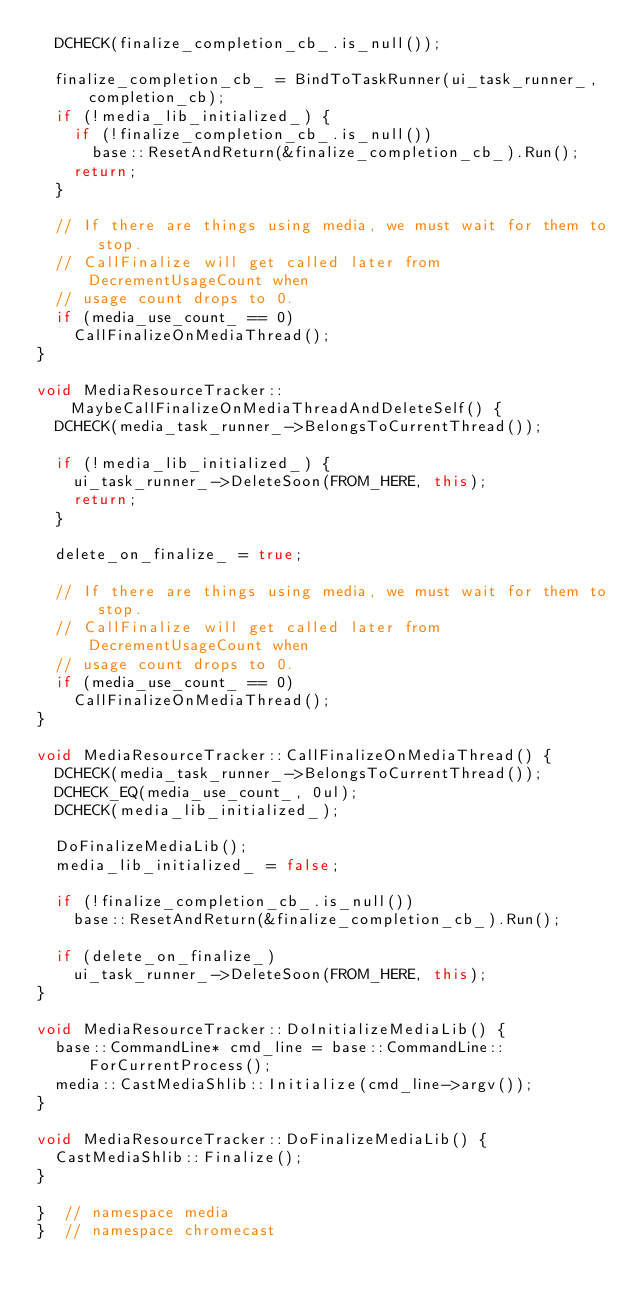<code> <loc_0><loc_0><loc_500><loc_500><_C++_>  DCHECK(finalize_completion_cb_.is_null());

  finalize_completion_cb_ = BindToTaskRunner(ui_task_runner_, completion_cb);
  if (!media_lib_initialized_) {
    if (!finalize_completion_cb_.is_null())
      base::ResetAndReturn(&finalize_completion_cb_).Run();
    return;
  }

  // If there are things using media, we must wait for them to stop.
  // CallFinalize will get called later from DecrementUsageCount when
  // usage count drops to 0.
  if (media_use_count_ == 0)
    CallFinalizeOnMediaThread();
}

void MediaResourceTracker::MaybeCallFinalizeOnMediaThreadAndDeleteSelf() {
  DCHECK(media_task_runner_->BelongsToCurrentThread());

  if (!media_lib_initialized_) {
    ui_task_runner_->DeleteSoon(FROM_HERE, this);
    return;
  }

  delete_on_finalize_ = true;

  // If there are things using media, we must wait for them to stop.
  // CallFinalize will get called later from DecrementUsageCount when
  // usage count drops to 0.
  if (media_use_count_ == 0)
    CallFinalizeOnMediaThread();
}

void MediaResourceTracker::CallFinalizeOnMediaThread() {
  DCHECK(media_task_runner_->BelongsToCurrentThread());
  DCHECK_EQ(media_use_count_, 0ul);
  DCHECK(media_lib_initialized_);

  DoFinalizeMediaLib();
  media_lib_initialized_ = false;

  if (!finalize_completion_cb_.is_null())
    base::ResetAndReturn(&finalize_completion_cb_).Run();

  if (delete_on_finalize_)
    ui_task_runner_->DeleteSoon(FROM_HERE, this);
}

void MediaResourceTracker::DoInitializeMediaLib() {
  base::CommandLine* cmd_line = base::CommandLine::ForCurrentProcess();
  media::CastMediaShlib::Initialize(cmd_line->argv());
}

void MediaResourceTracker::DoFinalizeMediaLib() {
  CastMediaShlib::Finalize();
}

}  // namespace media
}  // namespace chromecast
</code> 